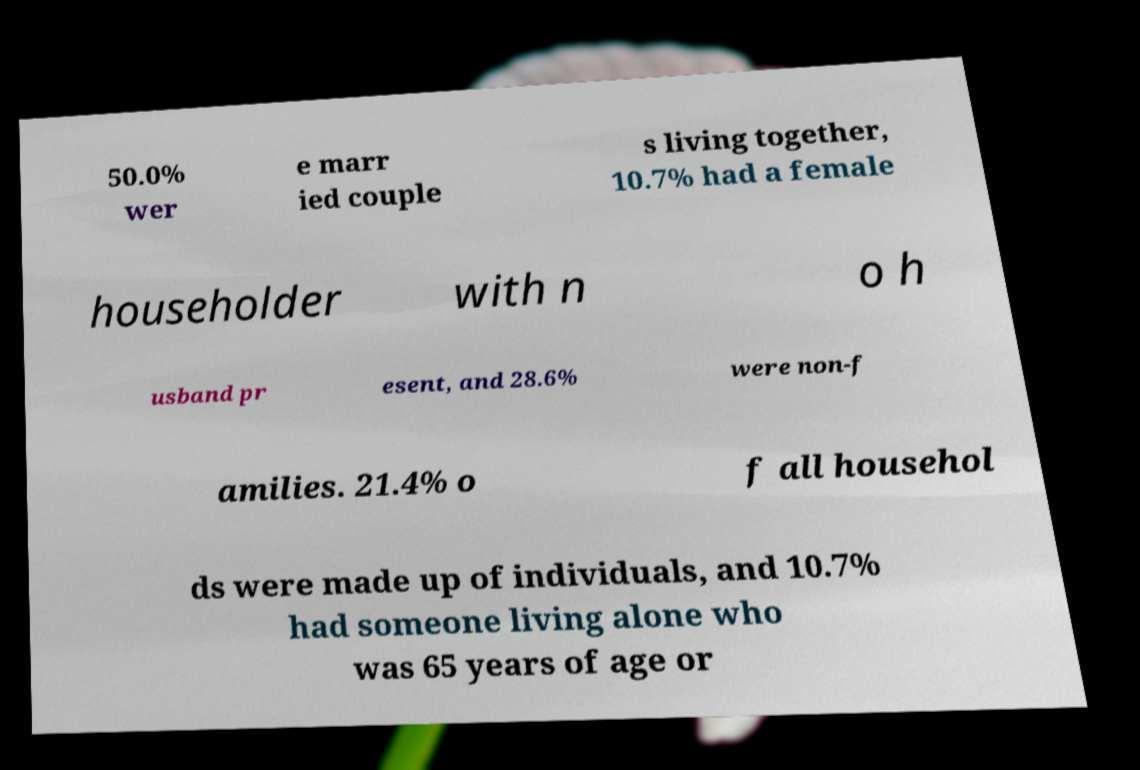Please read and relay the text visible in this image. What does it say? 50.0% wer e marr ied couple s living together, 10.7% had a female householder with n o h usband pr esent, and 28.6% were non-f amilies. 21.4% o f all househol ds were made up of individuals, and 10.7% had someone living alone who was 65 years of age or 